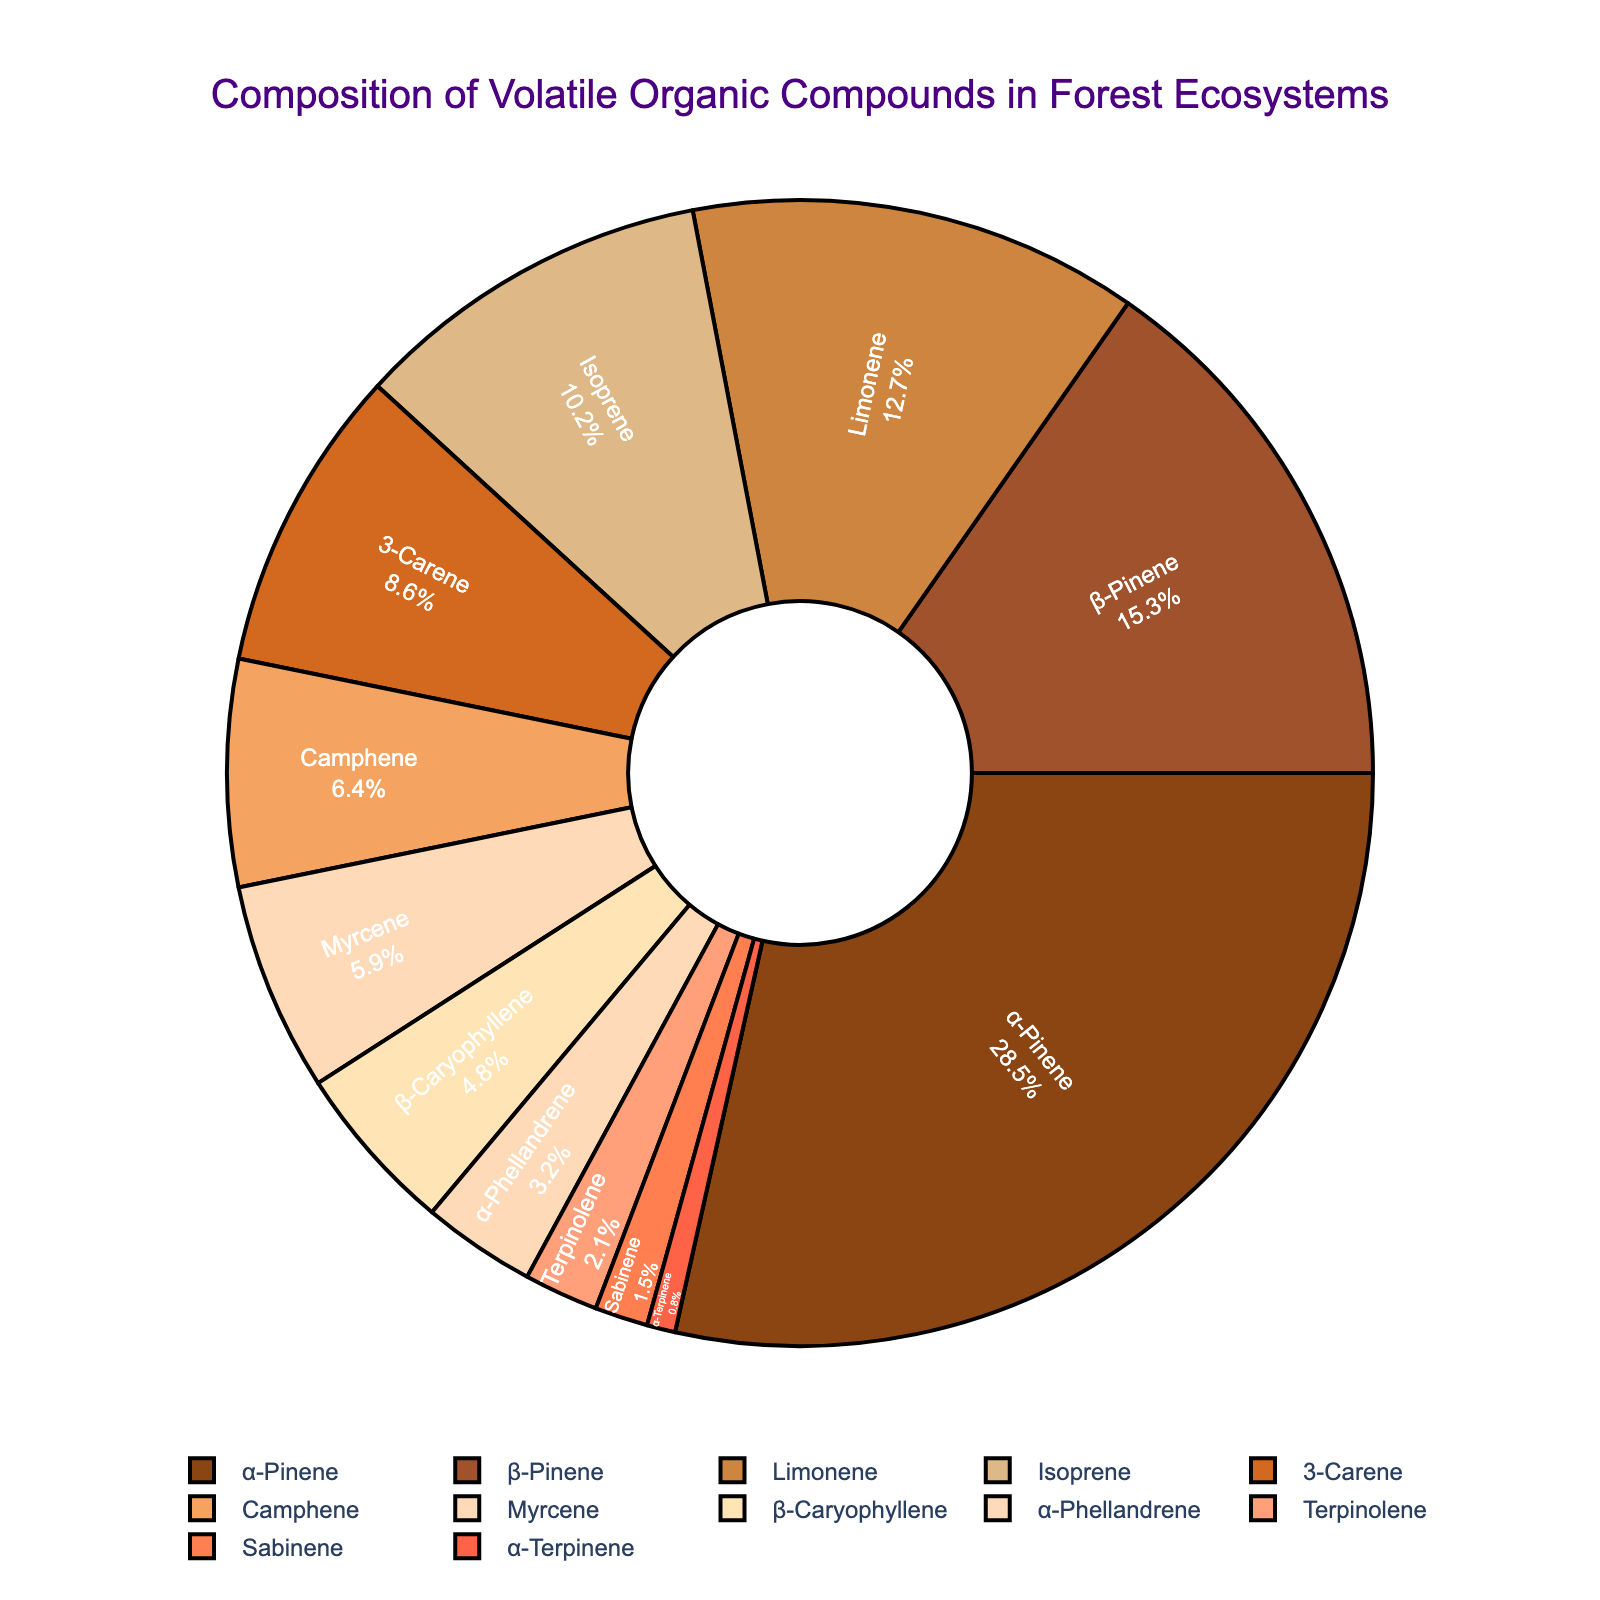Which compound has the highest percentage in the pie chart? The pie chart shows each compound and its corresponding percentage. Identify the compound with the largest slice.
Answer: α-Pinene Which compound occupies the smallest slice in the pie chart? Observe the segments of the pie chart and find the one with the smallest area.
Answer: α-Terpinene What is the combined percentage of α-Pinene and β-Pinene? Sum the percentages of α-Pinene (28.5%) and β-Pinene (15.3%). 28.5 + 15.3 = 43.8
Answer: 43.8 Is the percentage of Limonene greater than the percentage of Isoprene? Compare the percentages of Limonene (12.7%) and Isoprene (10.2%).
Answer: Yes How much more is the percentage of 3-Carene than that of Camphene? Subtract the percentage of Camphene (6.4%) from that of 3-Carene (8.6%). 8.6 - 6.4 = 2.2
Answer: 2.2 Which compound has the closest percentage to Myrcene? Identify the compound whose percentage is closest to Myrcene (5.9%), by comparing it to the percentages of all other compounds. Camphene (6.4%) is the closest.
Answer: Camphene What is the average percentage of the three compounds with the highest percentages? Identify the three compounds with the highest percentages: α-Pinene (28.5%), β-Pinene (15.3%), and Limonene (12.7%). Calculate the average: (28.5 + 15.3 + 12.7) / 3 = 56.5 / 3 = 18.83
Answer: 18.83 How many compounds have a percentage above 10%? Count the number of compounds whose percentages are greater than 10%: α-Pinene, β-Pinene, Limonene, and Isoprene are above 10%.
Answer: 4 What is the percentage difference between β-Caryophyllene and α-Phellandrene? Calculate the percentage difference between β-Caryophyllene (4.8%) and α-Phellandrene (3.2%). 4.8 - 3.2 = 1.6
Answer: 1.6 If you combine the percentages of all compounds with percentages less than 5%, what is the total percentage? Sum the percentages of compounds with less than 5%: Sabinene (1.5%), α-Terpinene (0.8%), Terpinolene (2.1%), and α-Phellandrene (3.2%). 1.5 + 0.8 + 2.1 + 3.2 = 7.6
Answer: 7.6 